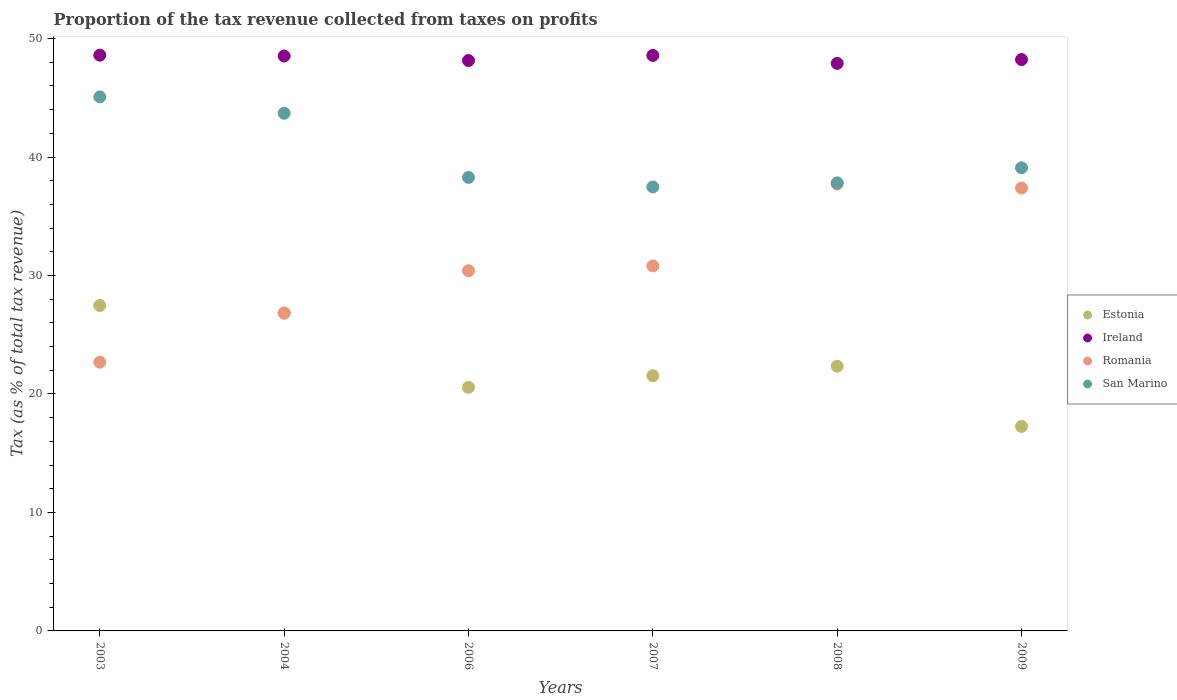How many different coloured dotlines are there?
Give a very brief answer. 4. What is the proportion of the tax revenue collected in Romania in 2003?
Ensure brevity in your answer.  22.68. Across all years, what is the maximum proportion of the tax revenue collected in San Marino?
Make the answer very short. 45.07. Across all years, what is the minimum proportion of the tax revenue collected in Ireland?
Your answer should be compact. 47.9. In which year was the proportion of the tax revenue collected in San Marino maximum?
Keep it short and to the point. 2003. What is the total proportion of the tax revenue collected in Ireland in the graph?
Your answer should be very brief. 289.97. What is the difference between the proportion of the tax revenue collected in Ireland in 2004 and that in 2008?
Your answer should be very brief. 0.62. What is the difference between the proportion of the tax revenue collected in San Marino in 2004 and the proportion of the tax revenue collected in Romania in 2008?
Give a very brief answer. 5.97. What is the average proportion of the tax revenue collected in Romania per year?
Ensure brevity in your answer.  30.97. In the year 2003, what is the difference between the proportion of the tax revenue collected in San Marino and proportion of the tax revenue collected in Romania?
Your answer should be very brief. 22.39. In how many years, is the proportion of the tax revenue collected in Romania greater than 22 %?
Make the answer very short. 6. What is the ratio of the proportion of the tax revenue collected in Ireland in 2004 to that in 2007?
Provide a succinct answer. 1. Is the proportion of the tax revenue collected in San Marino in 2007 less than that in 2009?
Ensure brevity in your answer.  Yes. Is the difference between the proportion of the tax revenue collected in San Marino in 2006 and 2007 greater than the difference between the proportion of the tax revenue collected in Romania in 2006 and 2007?
Your answer should be very brief. Yes. What is the difference between the highest and the second highest proportion of the tax revenue collected in Estonia?
Your response must be concise. 0.63. What is the difference between the highest and the lowest proportion of the tax revenue collected in Ireland?
Ensure brevity in your answer.  0.69. In how many years, is the proportion of the tax revenue collected in San Marino greater than the average proportion of the tax revenue collected in San Marino taken over all years?
Keep it short and to the point. 2. How many dotlines are there?
Keep it short and to the point. 4. What is the difference between two consecutive major ticks on the Y-axis?
Offer a very short reply. 10. Does the graph contain grids?
Provide a short and direct response. No. How many legend labels are there?
Keep it short and to the point. 4. What is the title of the graph?
Provide a succinct answer. Proportion of the tax revenue collected from taxes on profits. Does "East Asia (developing only)" appear as one of the legend labels in the graph?
Your answer should be very brief. No. What is the label or title of the X-axis?
Offer a very short reply. Years. What is the label or title of the Y-axis?
Provide a short and direct response. Tax (as % of total tax revenue). What is the Tax (as % of total tax revenue) in Estonia in 2003?
Ensure brevity in your answer.  27.47. What is the Tax (as % of total tax revenue) in Ireland in 2003?
Your response must be concise. 48.6. What is the Tax (as % of total tax revenue) in Romania in 2003?
Give a very brief answer. 22.68. What is the Tax (as % of total tax revenue) of San Marino in 2003?
Ensure brevity in your answer.  45.07. What is the Tax (as % of total tax revenue) of Estonia in 2004?
Keep it short and to the point. 26.84. What is the Tax (as % of total tax revenue) of Ireland in 2004?
Make the answer very short. 48.53. What is the Tax (as % of total tax revenue) in Romania in 2004?
Make the answer very short. 26.82. What is the Tax (as % of total tax revenue) of San Marino in 2004?
Your response must be concise. 43.69. What is the Tax (as % of total tax revenue) in Estonia in 2006?
Your answer should be very brief. 20.56. What is the Tax (as % of total tax revenue) in Ireland in 2006?
Provide a short and direct response. 48.14. What is the Tax (as % of total tax revenue) of Romania in 2006?
Your answer should be compact. 30.4. What is the Tax (as % of total tax revenue) of San Marino in 2006?
Your answer should be compact. 38.28. What is the Tax (as % of total tax revenue) in Estonia in 2007?
Your answer should be compact. 21.54. What is the Tax (as % of total tax revenue) of Ireland in 2007?
Your response must be concise. 48.57. What is the Tax (as % of total tax revenue) in Romania in 2007?
Offer a very short reply. 30.81. What is the Tax (as % of total tax revenue) of San Marino in 2007?
Your response must be concise. 37.47. What is the Tax (as % of total tax revenue) of Estonia in 2008?
Your answer should be very brief. 22.34. What is the Tax (as % of total tax revenue) of Ireland in 2008?
Make the answer very short. 47.9. What is the Tax (as % of total tax revenue) in Romania in 2008?
Keep it short and to the point. 37.72. What is the Tax (as % of total tax revenue) of San Marino in 2008?
Your answer should be very brief. 37.82. What is the Tax (as % of total tax revenue) in Estonia in 2009?
Offer a very short reply. 17.26. What is the Tax (as % of total tax revenue) in Ireland in 2009?
Make the answer very short. 48.22. What is the Tax (as % of total tax revenue) of Romania in 2009?
Provide a short and direct response. 37.38. What is the Tax (as % of total tax revenue) of San Marino in 2009?
Make the answer very short. 39.09. Across all years, what is the maximum Tax (as % of total tax revenue) of Estonia?
Keep it short and to the point. 27.47. Across all years, what is the maximum Tax (as % of total tax revenue) in Ireland?
Give a very brief answer. 48.6. Across all years, what is the maximum Tax (as % of total tax revenue) in Romania?
Make the answer very short. 37.72. Across all years, what is the maximum Tax (as % of total tax revenue) of San Marino?
Your answer should be very brief. 45.07. Across all years, what is the minimum Tax (as % of total tax revenue) in Estonia?
Give a very brief answer. 17.26. Across all years, what is the minimum Tax (as % of total tax revenue) of Ireland?
Ensure brevity in your answer.  47.9. Across all years, what is the minimum Tax (as % of total tax revenue) of Romania?
Your answer should be compact. 22.68. Across all years, what is the minimum Tax (as % of total tax revenue) in San Marino?
Ensure brevity in your answer.  37.47. What is the total Tax (as % of total tax revenue) of Estonia in the graph?
Ensure brevity in your answer.  136. What is the total Tax (as % of total tax revenue) of Ireland in the graph?
Give a very brief answer. 289.97. What is the total Tax (as % of total tax revenue) in Romania in the graph?
Give a very brief answer. 185.81. What is the total Tax (as % of total tax revenue) of San Marino in the graph?
Offer a very short reply. 241.42. What is the difference between the Tax (as % of total tax revenue) in Estonia in 2003 and that in 2004?
Ensure brevity in your answer.  0.63. What is the difference between the Tax (as % of total tax revenue) of Ireland in 2003 and that in 2004?
Provide a short and direct response. 0.07. What is the difference between the Tax (as % of total tax revenue) of Romania in 2003 and that in 2004?
Keep it short and to the point. -4.14. What is the difference between the Tax (as % of total tax revenue) of San Marino in 2003 and that in 2004?
Provide a short and direct response. 1.38. What is the difference between the Tax (as % of total tax revenue) in Estonia in 2003 and that in 2006?
Keep it short and to the point. 6.91. What is the difference between the Tax (as % of total tax revenue) in Ireland in 2003 and that in 2006?
Offer a terse response. 0.46. What is the difference between the Tax (as % of total tax revenue) of Romania in 2003 and that in 2006?
Ensure brevity in your answer.  -7.72. What is the difference between the Tax (as % of total tax revenue) in San Marino in 2003 and that in 2006?
Keep it short and to the point. 6.8. What is the difference between the Tax (as % of total tax revenue) in Estonia in 2003 and that in 2007?
Provide a succinct answer. 5.92. What is the difference between the Tax (as % of total tax revenue) in Ireland in 2003 and that in 2007?
Ensure brevity in your answer.  0.02. What is the difference between the Tax (as % of total tax revenue) in Romania in 2003 and that in 2007?
Your response must be concise. -8.13. What is the difference between the Tax (as % of total tax revenue) of San Marino in 2003 and that in 2007?
Your response must be concise. 7.6. What is the difference between the Tax (as % of total tax revenue) of Estonia in 2003 and that in 2008?
Ensure brevity in your answer.  5.12. What is the difference between the Tax (as % of total tax revenue) in Ireland in 2003 and that in 2008?
Make the answer very short. 0.69. What is the difference between the Tax (as % of total tax revenue) of Romania in 2003 and that in 2008?
Make the answer very short. -15.04. What is the difference between the Tax (as % of total tax revenue) of San Marino in 2003 and that in 2008?
Ensure brevity in your answer.  7.25. What is the difference between the Tax (as % of total tax revenue) of Estonia in 2003 and that in 2009?
Keep it short and to the point. 10.21. What is the difference between the Tax (as % of total tax revenue) of Ireland in 2003 and that in 2009?
Your answer should be very brief. 0.37. What is the difference between the Tax (as % of total tax revenue) of Romania in 2003 and that in 2009?
Ensure brevity in your answer.  -14.7. What is the difference between the Tax (as % of total tax revenue) of San Marino in 2003 and that in 2009?
Your answer should be compact. 5.98. What is the difference between the Tax (as % of total tax revenue) in Estonia in 2004 and that in 2006?
Give a very brief answer. 6.28. What is the difference between the Tax (as % of total tax revenue) in Ireland in 2004 and that in 2006?
Provide a succinct answer. 0.38. What is the difference between the Tax (as % of total tax revenue) of Romania in 2004 and that in 2006?
Provide a succinct answer. -3.58. What is the difference between the Tax (as % of total tax revenue) of San Marino in 2004 and that in 2006?
Keep it short and to the point. 5.42. What is the difference between the Tax (as % of total tax revenue) of Estonia in 2004 and that in 2007?
Offer a very short reply. 5.3. What is the difference between the Tax (as % of total tax revenue) in Ireland in 2004 and that in 2007?
Offer a very short reply. -0.05. What is the difference between the Tax (as % of total tax revenue) of Romania in 2004 and that in 2007?
Offer a very short reply. -3.99. What is the difference between the Tax (as % of total tax revenue) in San Marino in 2004 and that in 2007?
Provide a succinct answer. 6.22. What is the difference between the Tax (as % of total tax revenue) in Estonia in 2004 and that in 2008?
Ensure brevity in your answer.  4.5. What is the difference between the Tax (as % of total tax revenue) of Ireland in 2004 and that in 2008?
Your answer should be compact. 0.62. What is the difference between the Tax (as % of total tax revenue) in Romania in 2004 and that in 2008?
Offer a very short reply. -10.9. What is the difference between the Tax (as % of total tax revenue) in San Marino in 2004 and that in 2008?
Offer a very short reply. 5.87. What is the difference between the Tax (as % of total tax revenue) in Estonia in 2004 and that in 2009?
Make the answer very short. 9.58. What is the difference between the Tax (as % of total tax revenue) in Ireland in 2004 and that in 2009?
Offer a terse response. 0.3. What is the difference between the Tax (as % of total tax revenue) of Romania in 2004 and that in 2009?
Offer a terse response. -10.56. What is the difference between the Tax (as % of total tax revenue) in San Marino in 2004 and that in 2009?
Keep it short and to the point. 4.6. What is the difference between the Tax (as % of total tax revenue) of Estonia in 2006 and that in 2007?
Ensure brevity in your answer.  -0.98. What is the difference between the Tax (as % of total tax revenue) in Ireland in 2006 and that in 2007?
Keep it short and to the point. -0.43. What is the difference between the Tax (as % of total tax revenue) in Romania in 2006 and that in 2007?
Keep it short and to the point. -0.41. What is the difference between the Tax (as % of total tax revenue) in San Marino in 2006 and that in 2007?
Keep it short and to the point. 0.8. What is the difference between the Tax (as % of total tax revenue) of Estonia in 2006 and that in 2008?
Keep it short and to the point. -1.78. What is the difference between the Tax (as % of total tax revenue) in Ireland in 2006 and that in 2008?
Keep it short and to the point. 0.24. What is the difference between the Tax (as % of total tax revenue) in Romania in 2006 and that in 2008?
Ensure brevity in your answer.  -7.32. What is the difference between the Tax (as % of total tax revenue) of San Marino in 2006 and that in 2008?
Offer a terse response. 0.46. What is the difference between the Tax (as % of total tax revenue) in Estonia in 2006 and that in 2009?
Your answer should be compact. 3.3. What is the difference between the Tax (as % of total tax revenue) in Ireland in 2006 and that in 2009?
Your answer should be very brief. -0.08. What is the difference between the Tax (as % of total tax revenue) in Romania in 2006 and that in 2009?
Your response must be concise. -6.98. What is the difference between the Tax (as % of total tax revenue) of San Marino in 2006 and that in 2009?
Offer a terse response. -0.81. What is the difference between the Tax (as % of total tax revenue) of Estonia in 2007 and that in 2008?
Give a very brief answer. -0.8. What is the difference between the Tax (as % of total tax revenue) of Ireland in 2007 and that in 2008?
Ensure brevity in your answer.  0.67. What is the difference between the Tax (as % of total tax revenue) in Romania in 2007 and that in 2008?
Your response must be concise. -6.91. What is the difference between the Tax (as % of total tax revenue) in San Marino in 2007 and that in 2008?
Make the answer very short. -0.35. What is the difference between the Tax (as % of total tax revenue) of Estonia in 2007 and that in 2009?
Offer a terse response. 4.28. What is the difference between the Tax (as % of total tax revenue) of Ireland in 2007 and that in 2009?
Offer a very short reply. 0.35. What is the difference between the Tax (as % of total tax revenue) of Romania in 2007 and that in 2009?
Keep it short and to the point. -6.57. What is the difference between the Tax (as % of total tax revenue) of San Marino in 2007 and that in 2009?
Your answer should be very brief. -1.62. What is the difference between the Tax (as % of total tax revenue) of Estonia in 2008 and that in 2009?
Give a very brief answer. 5.08. What is the difference between the Tax (as % of total tax revenue) in Ireland in 2008 and that in 2009?
Your response must be concise. -0.32. What is the difference between the Tax (as % of total tax revenue) in Romania in 2008 and that in 2009?
Offer a very short reply. 0.34. What is the difference between the Tax (as % of total tax revenue) of San Marino in 2008 and that in 2009?
Your response must be concise. -1.27. What is the difference between the Tax (as % of total tax revenue) of Estonia in 2003 and the Tax (as % of total tax revenue) of Ireland in 2004?
Your response must be concise. -21.06. What is the difference between the Tax (as % of total tax revenue) of Estonia in 2003 and the Tax (as % of total tax revenue) of Romania in 2004?
Your answer should be very brief. 0.64. What is the difference between the Tax (as % of total tax revenue) in Estonia in 2003 and the Tax (as % of total tax revenue) in San Marino in 2004?
Keep it short and to the point. -16.23. What is the difference between the Tax (as % of total tax revenue) in Ireland in 2003 and the Tax (as % of total tax revenue) in Romania in 2004?
Provide a succinct answer. 21.78. What is the difference between the Tax (as % of total tax revenue) in Ireland in 2003 and the Tax (as % of total tax revenue) in San Marino in 2004?
Ensure brevity in your answer.  4.9. What is the difference between the Tax (as % of total tax revenue) of Romania in 2003 and the Tax (as % of total tax revenue) of San Marino in 2004?
Provide a short and direct response. -21.01. What is the difference between the Tax (as % of total tax revenue) of Estonia in 2003 and the Tax (as % of total tax revenue) of Ireland in 2006?
Give a very brief answer. -20.68. What is the difference between the Tax (as % of total tax revenue) in Estonia in 2003 and the Tax (as % of total tax revenue) in Romania in 2006?
Provide a succinct answer. -2.93. What is the difference between the Tax (as % of total tax revenue) of Estonia in 2003 and the Tax (as % of total tax revenue) of San Marino in 2006?
Your answer should be compact. -10.81. What is the difference between the Tax (as % of total tax revenue) in Ireland in 2003 and the Tax (as % of total tax revenue) in Romania in 2006?
Make the answer very short. 18.2. What is the difference between the Tax (as % of total tax revenue) of Ireland in 2003 and the Tax (as % of total tax revenue) of San Marino in 2006?
Your answer should be compact. 10.32. What is the difference between the Tax (as % of total tax revenue) of Romania in 2003 and the Tax (as % of total tax revenue) of San Marino in 2006?
Keep it short and to the point. -15.59. What is the difference between the Tax (as % of total tax revenue) in Estonia in 2003 and the Tax (as % of total tax revenue) in Ireland in 2007?
Your answer should be very brief. -21.11. What is the difference between the Tax (as % of total tax revenue) in Estonia in 2003 and the Tax (as % of total tax revenue) in Romania in 2007?
Your response must be concise. -3.34. What is the difference between the Tax (as % of total tax revenue) of Estonia in 2003 and the Tax (as % of total tax revenue) of San Marino in 2007?
Keep it short and to the point. -10.01. What is the difference between the Tax (as % of total tax revenue) of Ireland in 2003 and the Tax (as % of total tax revenue) of Romania in 2007?
Provide a short and direct response. 17.79. What is the difference between the Tax (as % of total tax revenue) of Ireland in 2003 and the Tax (as % of total tax revenue) of San Marino in 2007?
Make the answer very short. 11.13. What is the difference between the Tax (as % of total tax revenue) in Romania in 2003 and the Tax (as % of total tax revenue) in San Marino in 2007?
Your answer should be very brief. -14.79. What is the difference between the Tax (as % of total tax revenue) in Estonia in 2003 and the Tax (as % of total tax revenue) in Ireland in 2008?
Offer a terse response. -20.44. What is the difference between the Tax (as % of total tax revenue) in Estonia in 2003 and the Tax (as % of total tax revenue) in Romania in 2008?
Ensure brevity in your answer.  -10.25. What is the difference between the Tax (as % of total tax revenue) in Estonia in 2003 and the Tax (as % of total tax revenue) in San Marino in 2008?
Ensure brevity in your answer.  -10.35. What is the difference between the Tax (as % of total tax revenue) of Ireland in 2003 and the Tax (as % of total tax revenue) of Romania in 2008?
Offer a very short reply. 10.88. What is the difference between the Tax (as % of total tax revenue) in Ireland in 2003 and the Tax (as % of total tax revenue) in San Marino in 2008?
Give a very brief answer. 10.78. What is the difference between the Tax (as % of total tax revenue) of Romania in 2003 and the Tax (as % of total tax revenue) of San Marino in 2008?
Keep it short and to the point. -15.14. What is the difference between the Tax (as % of total tax revenue) of Estonia in 2003 and the Tax (as % of total tax revenue) of Ireland in 2009?
Keep it short and to the point. -20.76. What is the difference between the Tax (as % of total tax revenue) in Estonia in 2003 and the Tax (as % of total tax revenue) in Romania in 2009?
Give a very brief answer. -9.92. What is the difference between the Tax (as % of total tax revenue) in Estonia in 2003 and the Tax (as % of total tax revenue) in San Marino in 2009?
Provide a short and direct response. -11.62. What is the difference between the Tax (as % of total tax revenue) of Ireland in 2003 and the Tax (as % of total tax revenue) of Romania in 2009?
Provide a succinct answer. 11.22. What is the difference between the Tax (as % of total tax revenue) of Ireland in 2003 and the Tax (as % of total tax revenue) of San Marino in 2009?
Provide a succinct answer. 9.51. What is the difference between the Tax (as % of total tax revenue) in Romania in 2003 and the Tax (as % of total tax revenue) in San Marino in 2009?
Give a very brief answer. -16.41. What is the difference between the Tax (as % of total tax revenue) of Estonia in 2004 and the Tax (as % of total tax revenue) of Ireland in 2006?
Provide a succinct answer. -21.3. What is the difference between the Tax (as % of total tax revenue) in Estonia in 2004 and the Tax (as % of total tax revenue) in Romania in 2006?
Offer a very short reply. -3.56. What is the difference between the Tax (as % of total tax revenue) of Estonia in 2004 and the Tax (as % of total tax revenue) of San Marino in 2006?
Keep it short and to the point. -11.44. What is the difference between the Tax (as % of total tax revenue) in Ireland in 2004 and the Tax (as % of total tax revenue) in Romania in 2006?
Provide a succinct answer. 18.13. What is the difference between the Tax (as % of total tax revenue) of Ireland in 2004 and the Tax (as % of total tax revenue) of San Marino in 2006?
Provide a short and direct response. 10.25. What is the difference between the Tax (as % of total tax revenue) of Romania in 2004 and the Tax (as % of total tax revenue) of San Marino in 2006?
Your answer should be compact. -11.45. What is the difference between the Tax (as % of total tax revenue) in Estonia in 2004 and the Tax (as % of total tax revenue) in Ireland in 2007?
Provide a succinct answer. -21.74. What is the difference between the Tax (as % of total tax revenue) in Estonia in 2004 and the Tax (as % of total tax revenue) in Romania in 2007?
Your response must be concise. -3.97. What is the difference between the Tax (as % of total tax revenue) of Estonia in 2004 and the Tax (as % of total tax revenue) of San Marino in 2007?
Your answer should be compact. -10.63. What is the difference between the Tax (as % of total tax revenue) in Ireland in 2004 and the Tax (as % of total tax revenue) in Romania in 2007?
Offer a terse response. 17.72. What is the difference between the Tax (as % of total tax revenue) of Ireland in 2004 and the Tax (as % of total tax revenue) of San Marino in 2007?
Provide a succinct answer. 11.05. What is the difference between the Tax (as % of total tax revenue) of Romania in 2004 and the Tax (as % of total tax revenue) of San Marino in 2007?
Offer a very short reply. -10.65. What is the difference between the Tax (as % of total tax revenue) in Estonia in 2004 and the Tax (as % of total tax revenue) in Ireland in 2008?
Provide a short and direct response. -21.07. What is the difference between the Tax (as % of total tax revenue) of Estonia in 2004 and the Tax (as % of total tax revenue) of Romania in 2008?
Ensure brevity in your answer.  -10.88. What is the difference between the Tax (as % of total tax revenue) of Estonia in 2004 and the Tax (as % of total tax revenue) of San Marino in 2008?
Make the answer very short. -10.98. What is the difference between the Tax (as % of total tax revenue) in Ireland in 2004 and the Tax (as % of total tax revenue) in Romania in 2008?
Provide a short and direct response. 10.81. What is the difference between the Tax (as % of total tax revenue) of Ireland in 2004 and the Tax (as % of total tax revenue) of San Marino in 2008?
Provide a short and direct response. 10.7. What is the difference between the Tax (as % of total tax revenue) in Romania in 2004 and the Tax (as % of total tax revenue) in San Marino in 2008?
Ensure brevity in your answer.  -11. What is the difference between the Tax (as % of total tax revenue) in Estonia in 2004 and the Tax (as % of total tax revenue) in Ireland in 2009?
Give a very brief answer. -21.39. What is the difference between the Tax (as % of total tax revenue) in Estonia in 2004 and the Tax (as % of total tax revenue) in Romania in 2009?
Offer a terse response. -10.54. What is the difference between the Tax (as % of total tax revenue) in Estonia in 2004 and the Tax (as % of total tax revenue) in San Marino in 2009?
Give a very brief answer. -12.25. What is the difference between the Tax (as % of total tax revenue) in Ireland in 2004 and the Tax (as % of total tax revenue) in Romania in 2009?
Offer a very short reply. 11.14. What is the difference between the Tax (as % of total tax revenue) in Ireland in 2004 and the Tax (as % of total tax revenue) in San Marino in 2009?
Offer a very short reply. 9.44. What is the difference between the Tax (as % of total tax revenue) in Romania in 2004 and the Tax (as % of total tax revenue) in San Marino in 2009?
Your response must be concise. -12.27. What is the difference between the Tax (as % of total tax revenue) of Estonia in 2006 and the Tax (as % of total tax revenue) of Ireland in 2007?
Make the answer very short. -28.01. What is the difference between the Tax (as % of total tax revenue) in Estonia in 2006 and the Tax (as % of total tax revenue) in Romania in 2007?
Your answer should be very brief. -10.25. What is the difference between the Tax (as % of total tax revenue) of Estonia in 2006 and the Tax (as % of total tax revenue) of San Marino in 2007?
Keep it short and to the point. -16.91. What is the difference between the Tax (as % of total tax revenue) in Ireland in 2006 and the Tax (as % of total tax revenue) in Romania in 2007?
Your answer should be very brief. 17.33. What is the difference between the Tax (as % of total tax revenue) of Ireland in 2006 and the Tax (as % of total tax revenue) of San Marino in 2007?
Offer a terse response. 10.67. What is the difference between the Tax (as % of total tax revenue) in Romania in 2006 and the Tax (as % of total tax revenue) in San Marino in 2007?
Your answer should be very brief. -7.07. What is the difference between the Tax (as % of total tax revenue) of Estonia in 2006 and the Tax (as % of total tax revenue) of Ireland in 2008?
Provide a short and direct response. -27.35. What is the difference between the Tax (as % of total tax revenue) in Estonia in 2006 and the Tax (as % of total tax revenue) in Romania in 2008?
Provide a short and direct response. -17.16. What is the difference between the Tax (as % of total tax revenue) of Estonia in 2006 and the Tax (as % of total tax revenue) of San Marino in 2008?
Make the answer very short. -17.26. What is the difference between the Tax (as % of total tax revenue) of Ireland in 2006 and the Tax (as % of total tax revenue) of Romania in 2008?
Ensure brevity in your answer.  10.42. What is the difference between the Tax (as % of total tax revenue) of Ireland in 2006 and the Tax (as % of total tax revenue) of San Marino in 2008?
Ensure brevity in your answer.  10.32. What is the difference between the Tax (as % of total tax revenue) in Romania in 2006 and the Tax (as % of total tax revenue) in San Marino in 2008?
Make the answer very short. -7.42. What is the difference between the Tax (as % of total tax revenue) in Estonia in 2006 and the Tax (as % of total tax revenue) in Ireland in 2009?
Your response must be concise. -27.67. What is the difference between the Tax (as % of total tax revenue) of Estonia in 2006 and the Tax (as % of total tax revenue) of Romania in 2009?
Your answer should be very brief. -16.82. What is the difference between the Tax (as % of total tax revenue) in Estonia in 2006 and the Tax (as % of total tax revenue) in San Marino in 2009?
Offer a terse response. -18.53. What is the difference between the Tax (as % of total tax revenue) in Ireland in 2006 and the Tax (as % of total tax revenue) in Romania in 2009?
Your response must be concise. 10.76. What is the difference between the Tax (as % of total tax revenue) of Ireland in 2006 and the Tax (as % of total tax revenue) of San Marino in 2009?
Your response must be concise. 9.05. What is the difference between the Tax (as % of total tax revenue) in Romania in 2006 and the Tax (as % of total tax revenue) in San Marino in 2009?
Your answer should be very brief. -8.69. What is the difference between the Tax (as % of total tax revenue) in Estonia in 2007 and the Tax (as % of total tax revenue) in Ireland in 2008?
Your answer should be compact. -26.36. What is the difference between the Tax (as % of total tax revenue) of Estonia in 2007 and the Tax (as % of total tax revenue) of Romania in 2008?
Your answer should be very brief. -16.18. What is the difference between the Tax (as % of total tax revenue) of Estonia in 2007 and the Tax (as % of total tax revenue) of San Marino in 2008?
Give a very brief answer. -16.28. What is the difference between the Tax (as % of total tax revenue) in Ireland in 2007 and the Tax (as % of total tax revenue) in Romania in 2008?
Your response must be concise. 10.85. What is the difference between the Tax (as % of total tax revenue) of Ireland in 2007 and the Tax (as % of total tax revenue) of San Marino in 2008?
Ensure brevity in your answer.  10.75. What is the difference between the Tax (as % of total tax revenue) of Romania in 2007 and the Tax (as % of total tax revenue) of San Marino in 2008?
Make the answer very short. -7.01. What is the difference between the Tax (as % of total tax revenue) in Estonia in 2007 and the Tax (as % of total tax revenue) in Ireland in 2009?
Ensure brevity in your answer.  -26.68. What is the difference between the Tax (as % of total tax revenue) in Estonia in 2007 and the Tax (as % of total tax revenue) in Romania in 2009?
Offer a very short reply. -15.84. What is the difference between the Tax (as % of total tax revenue) in Estonia in 2007 and the Tax (as % of total tax revenue) in San Marino in 2009?
Offer a terse response. -17.55. What is the difference between the Tax (as % of total tax revenue) of Ireland in 2007 and the Tax (as % of total tax revenue) of Romania in 2009?
Ensure brevity in your answer.  11.19. What is the difference between the Tax (as % of total tax revenue) in Ireland in 2007 and the Tax (as % of total tax revenue) in San Marino in 2009?
Keep it short and to the point. 9.48. What is the difference between the Tax (as % of total tax revenue) of Romania in 2007 and the Tax (as % of total tax revenue) of San Marino in 2009?
Offer a very short reply. -8.28. What is the difference between the Tax (as % of total tax revenue) of Estonia in 2008 and the Tax (as % of total tax revenue) of Ireland in 2009?
Your answer should be very brief. -25.88. What is the difference between the Tax (as % of total tax revenue) of Estonia in 2008 and the Tax (as % of total tax revenue) of Romania in 2009?
Ensure brevity in your answer.  -15.04. What is the difference between the Tax (as % of total tax revenue) in Estonia in 2008 and the Tax (as % of total tax revenue) in San Marino in 2009?
Give a very brief answer. -16.75. What is the difference between the Tax (as % of total tax revenue) in Ireland in 2008 and the Tax (as % of total tax revenue) in Romania in 2009?
Keep it short and to the point. 10.52. What is the difference between the Tax (as % of total tax revenue) of Ireland in 2008 and the Tax (as % of total tax revenue) of San Marino in 2009?
Keep it short and to the point. 8.81. What is the difference between the Tax (as % of total tax revenue) of Romania in 2008 and the Tax (as % of total tax revenue) of San Marino in 2009?
Your answer should be compact. -1.37. What is the average Tax (as % of total tax revenue) in Estonia per year?
Give a very brief answer. 22.67. What is the average Tax (as % of total tax revenue) of Ireland per year?
Offer a very short reply. 48.33. What is the average Tax (as % of total tax revenue) in Romania per year?
Your response must be concise. 30.97. What is the average Tax (as % of total tax revenue) in San Marino per year?
Provide a succinct answer. 40.24. In the year 2003, what is the difference between the Tax (as % of total tax revenue) in Estonia and Tax (as % of total tax revenue) in Ireland?
Your answer should be very brief. -21.13. In the year 2003, what is the difference between the Tax (as % of total tax revenue) in Estonia and Tax (as % of total tax revenue) in Romania?
Your answer should be very brief. 4.78. In the year 2003, what is the difference between the Tax (as % of total tax revenue) in Estonia and Tax (as % of total tax revenue) in San Marino?
Give a very brief answer. -17.61. In the year 2003, what is the difference between the Tax (as % of total tax revenue) in Ireland and Tax (as % of total tax revenue) in Romania?
Your answer should be very brief. 25.92. In the year 2003, what is the difference between the Tax (as % of total tax revenue) in Ireland and Tax (as % of total tax revenue) in San Marino?
Provide a succinct answer. 3.52. In the year 2003, what is the difference between the Tax (as % of total tax revenue) of Romania and Tax (as % of total tax revenue) of San Marino?
Your answer should be very brief. -22.39. In the year 2004, what is the difference between the Tax (as % of total tax revenue) in Estonia and Tax (as % of total tax revenue) in Ireland?
Provide a succinct answer. -21.69. In the year 2004, what is the difference between the Tax (as % of total tax revenue) in Estonia and Tax (as % of total tax revenue) in Romania?
Ensure brevity in your answer.  0.02. In the year 2004, what is the difference between the Tax (as % of total tax revenue) in Estonia and Tax (as % of total tax revenue) in San Marino?
Give a very brief answer. -16.86. In the year 2004, what is the difference between the Tax (as % of total tax revenue) of Ireland and Tax (as % of total tax revenue) of Romania?
Provide a short and direct response. 21.7. In the year 2004, what is the difference between the Tax (as % of total tax revenue) of Ireland and Tax (as % of total tax revenue) of San Marino?
Your answer should be compact. 4.83. In the year 2004, what is the difference between the Tax (as % of total tax revenue) in Romania and Tax (as % of total tax revenue) in San Marino?
Offer a terse response. -16.87. In the year 2006, what is the difference between the Tax (as % of total tax revenue) of Estonia and Tax (as % of total tax revenue) of Ireland?
Offer a terse response. -27.58. In the year 2006, what is the difference between the Tax (as % of total tax revenue) of Estonia and Tax (as % of total tax revenue) of Romania?
Ensure brevity in your answer.  -9.84. In the year 2006, what is the difference between the Tax (as % of total tax revenue) of Estonia and Tax (as % of total tax revenue) of San Marino?
Make the answer very short. -17.72. In the year 2006, what is the difference between the Tax (as % of total tax revenue) in Ireland and Tax (as % of total tax revenue) in Romania?
Your response must be concise. 17.74. In the year 2006, what is the difference between the Tax (as % of total tax revenue) in Ireland and Tax (as % of total tax revenue) in San Marino?
Make the answer very short. 9.87. In the year 2006, what is the difference between the Tax (as % of total tax revenue) of Romania and Tax (as % of total tax revenue) of San Marino?
Provide a succinct answer. -7.88. In the year 2007, what is the difference between the Tax (as % of total tax revenue) of Estonia and Tax (as % of total tax revenue) of Ireland?
Offer a very short reply. -27.03. In the year 2007, what is the difference between the Tax (as % of total tax revenue) in Estonia and Tax (as % of total tax revenue) in Romania?
Keep it short and to the point. -9.27. In the year 2007, what is the difference between the Tax (as % of total tax revenue) of Estonia and Tax (as % of total tax revenue) of San Marino?
Your response must be concise. -15.93. In the year 2007, what is the difference between the Tax (as % of total tax revenue) of Ireland and Tax (as % of total tax revenue) of Romania?
Ensure brevity in your answer.  17.76. In the year 2007, what is the difference between the Tax (as % of total tax revenue) of Ireland and Tax (as % of total tax revenue) of San Marino?
Your answer should be compact. 11.1. In the year 2007, what is the difference between the Tax (as % of total tax revenue) of Romania and Tax (as % of total tax revenue) of San Marino?
Ensure brevity in your answer.  -6.66. In the year 2008, what is the difference between the Tax (as % of total tax revenue) of Estonia and Tax (as % of total tax revenue) of Ireland?
Your response must be concise. -25.56. In the year 2008, what is the difference between the Tax (as % of total tax revenue) of Estonia and Tax (as % of total tax revenue) of Romania?
Offer a very short reply. -15.38. In the year 2008, what is the difference between the Tax (as % of total tax revenue) of Estonia and Tax (as % of total tax revenue) of San Marino?
Provide a short and direct response. -15.48. In the year 2008, what is the difference between the Tax (as % of total tax revenue) of Ireland and Tax (as % of total tax revenue) of Romania?
Offer a very short reply. 10.18. In the year 2008, what is the difference between the Tax (as % of total tax revenue) of Ireland and Tax (as % of total tax revenue) of San Marino?
Your answer should be very brief. 10.08. In the year 2008, what is the difference between the Tax (as % of total tax revenue) of Romania and Tax (as % of total tax revenue) of San Marino?
Give a very brief answer. -0.1. In the year 2009, what is the difference between the Tax (as % of total tax revenue) of Estonia and Tax (as % of total tax revenue) of Ireland?
Provide a succinct answer. -30.97. In the year 2009, what is the difference between the Tax (as % of total tax revenue) in Estonia and Tax (as % of total tax revenue) in Romania?
Offer a very short reply. -20.12. In the year 2009, what is the difference between the Tax (as % of total tax revenue) of Estonia and Tax (as % of total tax revenue) of San Marino?
Your answer should be compact. -21.83. In the year 2009, what is the difference between the Tax (as % of total tax revenue) of Ireland and Tax (as % of total tax revenue) of Romania?
Offer a terse response. 10.84. In the year 2009, what is the difference between the Tax (as % of total tax revenue) in Ireland and Tax (as % of total tax revenue) in San Marino?
Give a very brief answer. 9.13. In the year 2009, what is the difference between the Tax (as % of total tax revenue) of Romania and Tax (as % of total tax revenue) of San Marino?
Ensure brevity in your answer.  -1.71. What is the ratio of the Tax (as % of total tax revenue) in Estonia in 2003 to that in 2004?
Give a very brief answer. 1.02. What is the ratio of the Tax (as % of total tax revenue) of Romania in 2003 to that in 2004?
Your answer should be compact. 0.85. What is the ratio of the Tax (as % of total tax revenue) of San Marino in 2003 to that in 2004?
Keep it short and to the point. 1.03. What is the ratio of the Tax (as % of total tax revenue) of Estonia in 2003 to that in 2006?
Your answer should be very brief. 1.34. What is the ratio of the Tax (as % of total tax revenue) of Ireland in 2003 to that in 2006?
Keep it short and to the point. 1.01. What is the ratio of the Tax (as % of total tax revenue) in Romania in 2003 to that in 2006?
Your response must be concise. 0.75. What is the ratio of the Tax (as % of total tax revenue) in San Marino in 2003 to that in 2006?
Your answer should be very brief. 1.18. What is the ratio of the Tax (as % of total tax revenue) in Estonia in 2003 to that in 2007?
Offer a terse response. 1.27. What is the ratio of the Tax (as % of total tax revenue) of Ireland in 2003 to that in 2007?
Your answer should be compact. 1. What is the ratio of the Tax (as % of total tax revenue) of Romania in 2003 to that in 2007?
Keep it short and to the point. 0.74. What is the ratio of the Tax (as % of total tax revenue) of San Marino in 2003 to that in 2007?
Your answer should be compact. 1.2. What is the ratio of the Tax (as % of total tax revenue) in Estonia in 2003 to that in 2008?
Your response must be concise. 1.23. What is the ratio of the Tax (as % of total tax revenue) of Ireland in 2003 to that in 2008?
Your response must be concise. 1.01. What is the ratio of the Tax (as % of total tax revenue) in Romania in 2003 to that in 2008?
Your answer should be very brief. 0.6. What is the ratio of the Tax (as % of total tax revenue) in San Marino in 2003 to that in 2008?
Your response must be concise. 1.19. What is the ratio of the Tax (as % of total tax revenue) of Estonia in 2003 to that in 2009?
Give a very brief answer. 1.59. What is the ratio of the Tax (as % of total tax revenue) in Ireland in 2003 to that in 2009?
Your response must be concise. 1.01. What is the ratio of the Tax (as % of total tax revenue) of Romania in 2003 to that in 2009?
Provide a short and direct response. 0.61. What is the ratio of the Tax (as % of total tax revenue) of San Marino in 2003 to that in 2009?
Your answer should be compact. 1.15. What is the ratio of the Tax (as % of total tax revenue) in Estonia in 2004 to that in 2006?
Make the answer very short. 1.31. What is the ratio of the Tax (as % of total tax revenue) in Ireland in 2004 to that in 2006?
Your answer should be compact. 1.01. What is the ratio of the Tax (as % of total tax revenue) in Romania in 2004 to that in 2006?
Give a very brief answer. 0.88. What is the ratio of the Tax (as % of total tax revenue) in San Marino in 2004 to that in 2006?
Make the answer very short. 1.14. What is the ratio of the Tax (as % of total tax revenue) in Estonia in 2004 to that in 2007?
Your response must be concise. 1.25. What is the ratio of the Tax (as % of total tax revenue) of Ireland in 2004 to that in 2007?
Provide a succinct answer. 1. What is the ratio of the Tax (as % of total tax revenue) in Romania in 2004 to that in 2007?
Your answer should be compact. 0.87. What is the ratio of the Tax (as % of total tax revenue) of San Marino in 2004 to that in 2007?
Provide a succinct answer. 1.17. What is the ratio of the Tax (as % of total tax revenue) in Estonia in 2004 to that in 2008?
Your answer should be compact. 1.2. What is the ratio of the Tax (as % of total tax revenue) of Romania in 2004 to that in 2008?
Ensure brevity in your answer.  0.71. What is the ratio of the Tax (as % of total tax revenue) in San Marino in 2004 to that in 2008?
Your answer should be compact. 1.16. What is the ratio of the Tax (as % of total tax revenue) of Estonia in 2004 to that in 2009?
Make the answer very short. 1.56. What is the ratio of the Tax (as % of total tax revenue) in Ireland in 2004 to that in 2009?
Your answer should be compact. 1.01. What is the ratio of the Tax (as % of total tax revenue) in Romania in 2004 to that in 2009?
Your answer should be very brief. 0.72. What is the ratio of the Tax (as % of total tax revenue) in San Marino in 2004 to that in 2009?
Your answer should be very brief. 1.12. What is the ratio of the Tax (as % of total tax revenue) of Estonia in 2006 to that in 2007?
Provide a short and direct response. 0.95. What is the ratio of the Tax (as % of total tax revenue) in Romania in 2006 to that in 2007?
Offer a terse response. 0.99. What is the ratio of the Tax (as % of total tax revenue) in San Marino in 2006 to that in 2007?
Offer a very short reply. 1.02. What is the ratio of the Tax (as % of total tax revenue) in Estonia in 2006 to that in 2008?
Your answer should be compact. 0.92. What is the ratio of the Tax (as % of total tax revenue) in Ireland in 2006 to that in 2008?
Give a very brief answer. 1. What is the ratio of the Tax (as % of total tax revenue) of Romania in 2006 to that in 2008?
Offer a terse response. 0.81. What is the ratio of the Tax (as % of total tax revenue) of San Marino in 2006 to that in 2008?
Your answer should be very brief. 1.01. What is the ratio of the Tax (as % of total tax revenue) of Estonia in 2006 to that in 2009?
Provide a succinct answer. 1.19. What is the ratio of the Tax (as % of total tax revenue) of Ireland in 2006 to that in 2009?
Ensure brevity in your answer.  1. What is the ratio of the Tax (as % of total tax revenue) of Romania in 2006 to that in 2009?
Keep it short and to the point. 0.81. What is the ratio of the Tax (as % of total tax revenue) of San Marino in 2006 to that in 2009?
Your response must be concise. 0.98. What is the ratio of the Tax (as % of total tax revenue) in Estonia in 2007 to that in 2008?
Your answer should be compact. 0.96. What is the ratio of the Tax (as % of total tax revenue) of Romania in 2007 to that in 2008?
Your answer should be very brief. 0.82. What is the ratio of the Tax (as % of total tax revenue) of San Marino in 2007 to that in 2008?
Give a very brief answer. 0.99. What is the ratio of the Tax (as % of total tax revenue) of Estonia in 2007 to that in 2009?
Provide a succinct answer. 1.25. What is the ratio of the Tax (as % of total tax revenue) of Romania in 2007 to that in 2009?
Keep it short and to the point. 0.82. What is the ratio of the Tax (as % of total tax revenue) of San Marino in 2007 to that in 2009?
Keep it short and to the point. 0.96. What is the ratio of the Tax (as % of total tax revenue) in Estonia in 2008 to that in 2009?
Offer a terse response. 1.29. What is the ratio of the Tax (as % of total tax revenue) of Romania in 2008 to that in 2009?
Give a very brief answer. 1.01. What is the ratio of the Tax (as % of total tax revenue) in San Marino in 2008 to that in 2009?
Give a very brief answer. 0.97. What is the difference between the highest and the second highest Tax (as % of total tax revenue) of Estonia?
Ensure brevity in your answer.  0.63. What is the difference between the highest and the second highest Tax (as % of total tax revenue) in Ireland?
Make the answer very short. 0.02. What is the difference between the highest and the second highest Tax (as % of total tax revenue) of Romania?
Keep it short and to the point. 0.34. What is the difference between the highest and the second highest Tax (as % of total tax revenue) in San Marino?
Your answer should be compact. 1.38. What is the difference between the highest and the lowest Tax (as % of total tax revenue) of Estonia?
Your answer should be compact. 10.21. What is the difference between the highest and the lowest Tax (as % of total tax revenue) of Ireland?
Your response must be concise. 0.69. What is the difference between the highest and the lowest Tax (as % of total tax revenue) in Romania?
Your response must be concise. 15.04. What is the difference between the highest and the lowest Tax (as % of total tax revenue) in San Marino?
Make the answer very short. 7.6. 